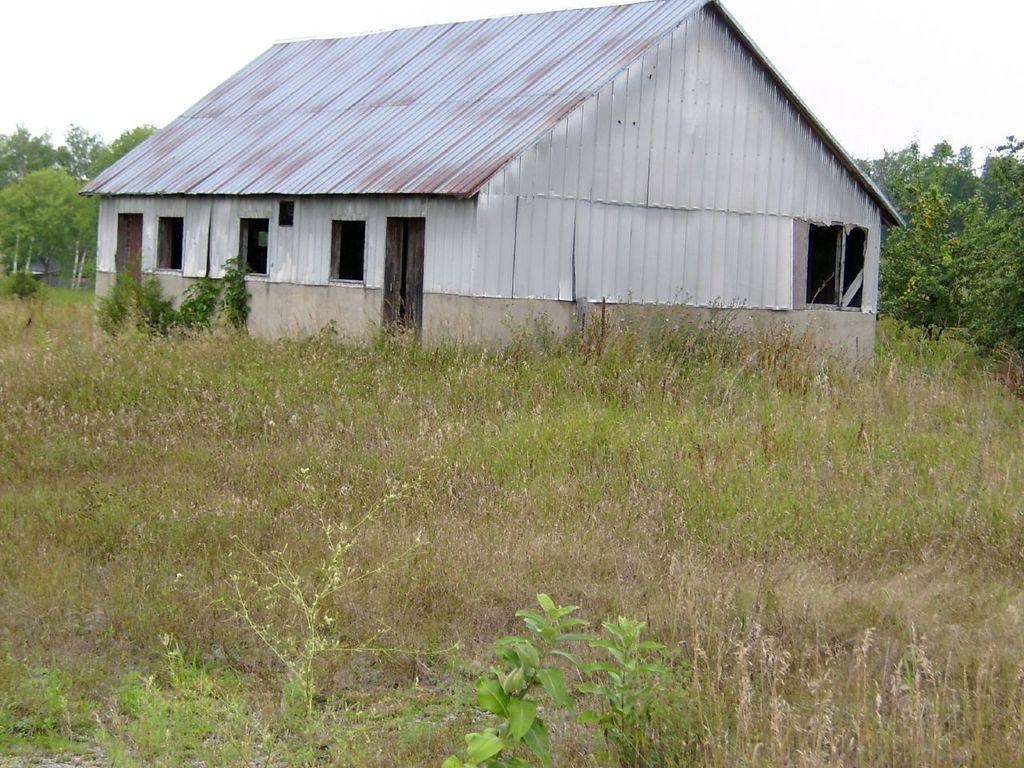What type of structure is present in the image? There is a metal shed house construction in the image. What is the ground cover visible in the image? There is green grass visible in the image. Are there any plants in the image? Yes, there are plants in the image. Where are the trees located in the image? There are trees on both the left and right sides of the image. What type of behavior does the monkey exhibit in the image? There is no monkey present in the image, so it is not possible to describe its behavior. 